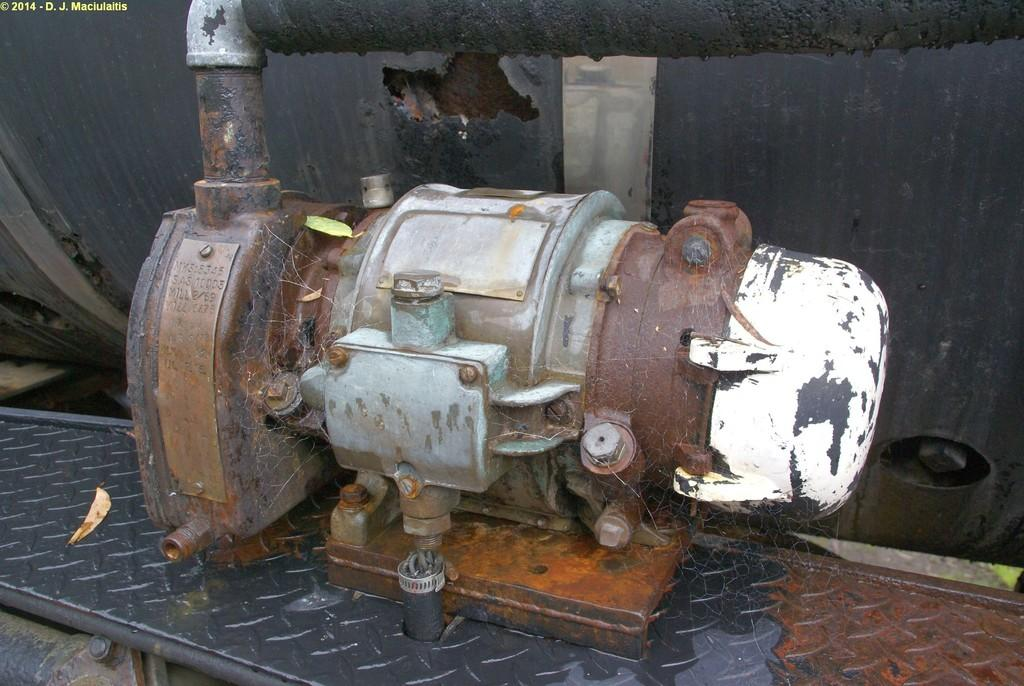What type of object is the main subject of the image? There is an old motor in the image. Can you describe the condition of the motor? The motor has rust on it. What color is the motor? The motor has white paint. How is the motor attached to other objects? The motor is fitted with screws and attached to an iron bar. What type of disease can be seen affecting the motor in the image? There is no disease present in the image; it is an old motor with rust on it. Can you tell me how many parcels are stacked on top of the motor in the image? There are no parcels present in the image; it only features an old motor with rust on it, white paint, screws, and an iron bar. 